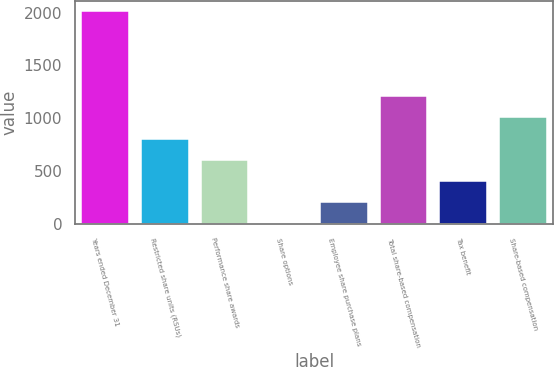Convert chart to OTSL. <chart><loc_0><loc_0><loc_500><loc_500><bar_chart><fcel>Years ended December 31<fcel>Restricted share units (RSUs)<fcel>Performance share awards<fcel>Share options<fcel>Employee share purchase plans<fcel>Total share-based compensation<fcel>Tax benefit<fcel>Share-based compensation<nl><fcel>2013<fcel>806.4<fcel>605.3<fcel>2<fcel>203.1<fcel>1208.6<fcel>404.2<fcel>1007.5<nl></chart> 